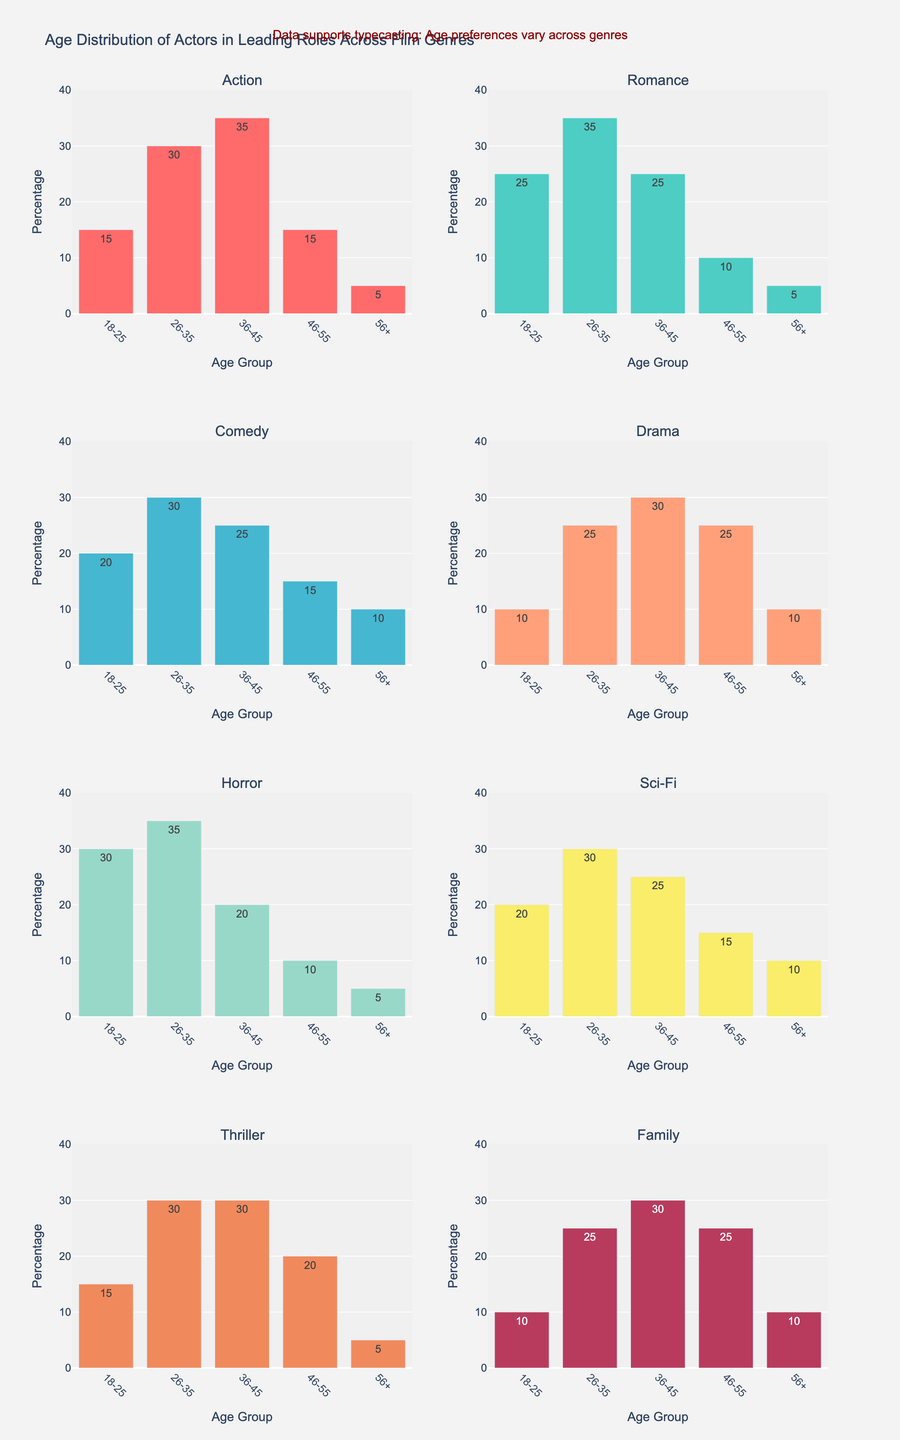what is the title of the figure? The title is usually found at the top of the figure and describes the content or purpose of the visual.
Answer: Age Distribution of Actors in Leading Roles Across Film Genres What is the highest percentage for each genre? To find the highest percentage, look at the bar representing each age group within each subplot and identify the tallest bar. For instance, for Action, the tallest bar corresponds to the 36-45 age group.
Answer: Action: 36-45, Romance: 26-35, Comedy: 26-35, Drama: 36-45, Horror: 26-35, Sci-Fi: 26-35, Thriller: 26-35 & 36-45 (tie), Family: 36-45 Which genre has the highest percentage of actors aged 18-25? Compare the heights of the bars for the 18-25 age group across all subplots. The genre with the tallest bar for this age group has the highest percentage.
Answer: Horror What is the sum of actor percentages aged 36-45 in Drama, Comedy, and Family genres? First, identify the percentage of actors aged 36-45 in each genre by locating the corresponding bars: Drama (30), Comedy (25), Family (30). Then sum these values: 30 + 25 + 30 = 85.
Answer: 85% Which genres have an equal distribution of actors aged 56+? Look for the 56+ age group bars across all subplots and identify the ones that have the same height. Action, Romance, Horror, and Thriller all have bars of the same height (5) for this age group.
Answer: Action, Romance, Horror, Thriller Which age group generally has the lowest percentage across all genres? Examine all subplots and identify which age group consistently has smaller bars across most or all genres. Most genres have the 56+ age group as the shortest.
Answer: 56+ How do the age distributions in Action and Thriller genres compare? Compare the heights of bars for each age group in the Action subplot to those in the Thriller subplot. They are similar, with both having higher percentages in mid-range age groups but Action has slightly lower 46-55 and higher percentage for 36-45.
Answer: Similar, with mid-range dominance and minor differences in specific age groups Which age group is consistently most represented in leading roles for Family movies? Examine the Family subplot and determine the tallest bar. The 36-45 age group has the tallest bar.
Answer: 36-45 What is the difference in actor percentages aged 26-35 between Romance and Sci-Fi genres? Locate the 26-35 age group bars for Romance (35) and Sci-Fi (30). The difference is 35 - 30 = 5.
Answer: 5% What can be inferred about the preference for older actors (aged 56+) in different genres? By examining the height of the bars for the 56+ age group across all subplots, one can observe that older actors are least represented in Action, Romance, Horror, and Thriller genres. This suggests a general trend of fewer older actors in leading roles.
Answer: Older actors are least represented in several genres 